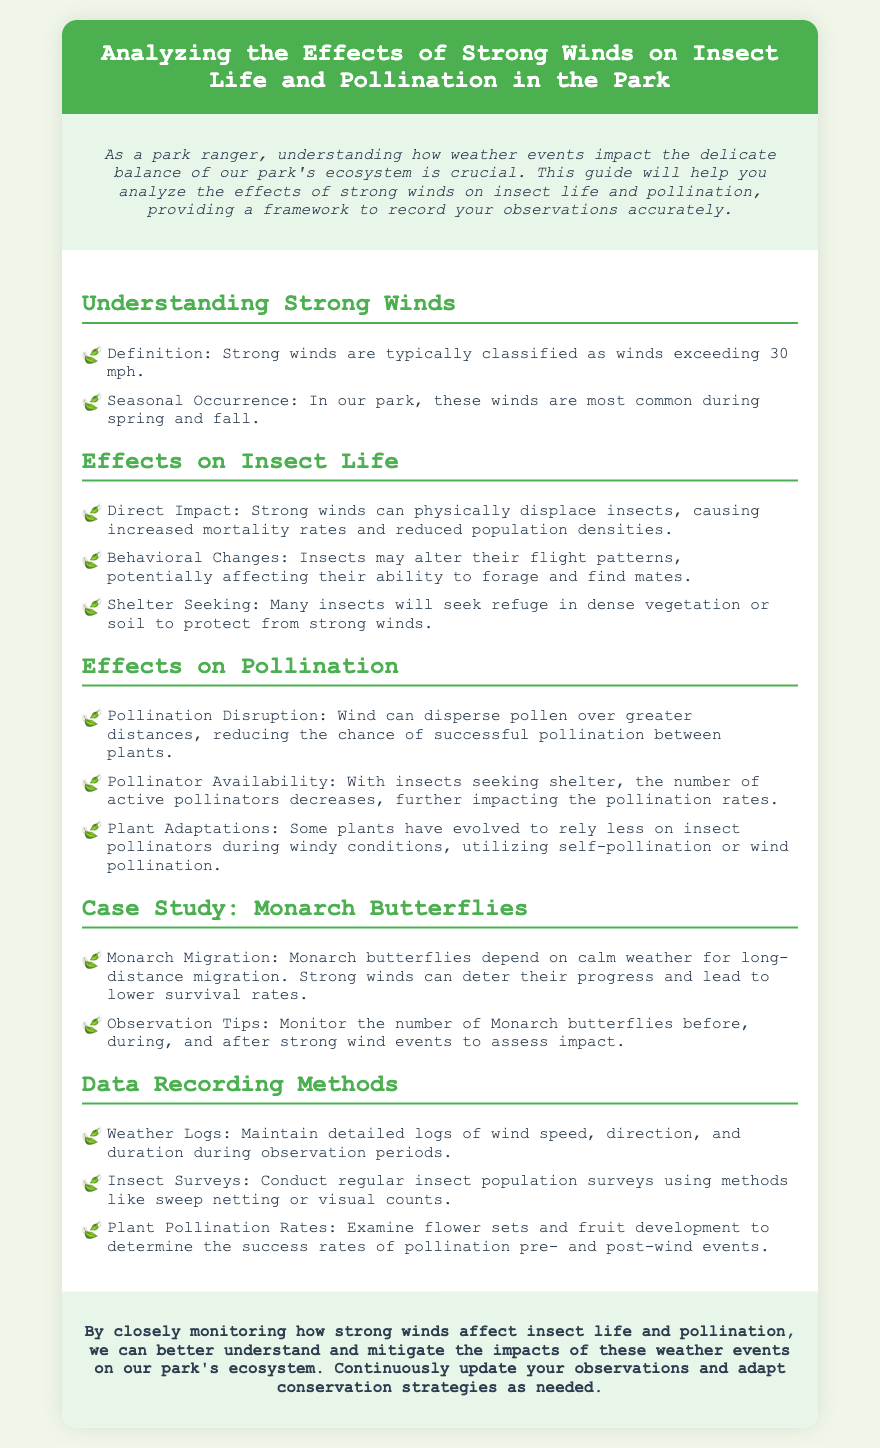What is classified as strong winds? The document states that strong winds are classified as winds exceeding 30 mph.
Answer: winds exceeding 30 mph When are strong winds most common in the park? It is mentioned that strong winds are most common during spring and fall.
Answer: spring and fall What direct impact do strong winds have on insects? The document indicates that strong winds can cause increased mortality rates and reduced population densities.
Answer: increased mortality rates What adaptation do some plants make regarding pollination during windy conditions? The text notes that some plants have evolved to rely less on insect pollinators during windy conditions.
Answer: self-pollination or wind pollination What is one observation tip for monitoring Monarch butterflies? The document suggests monitoring the number of Monarch butterflies before, during, and after strong wind events.
Answer: before, during, and after strong wind events What method is recommended for conducting insect population surveys? It is mentioned that methods like sweep netting or visual counts can be used for insect surveys.
Answer: sweep netting or visual counts What can be maintained to record weather conditions? The document states that detailed logs of wind speed, direction, and duration should be kept.
Answer: detailed logs What should be examined to determine pollination success rates? The document mentions examining flower sets and fruit development for assessing pollination success rates.
Answer: flower sets and fruit development 